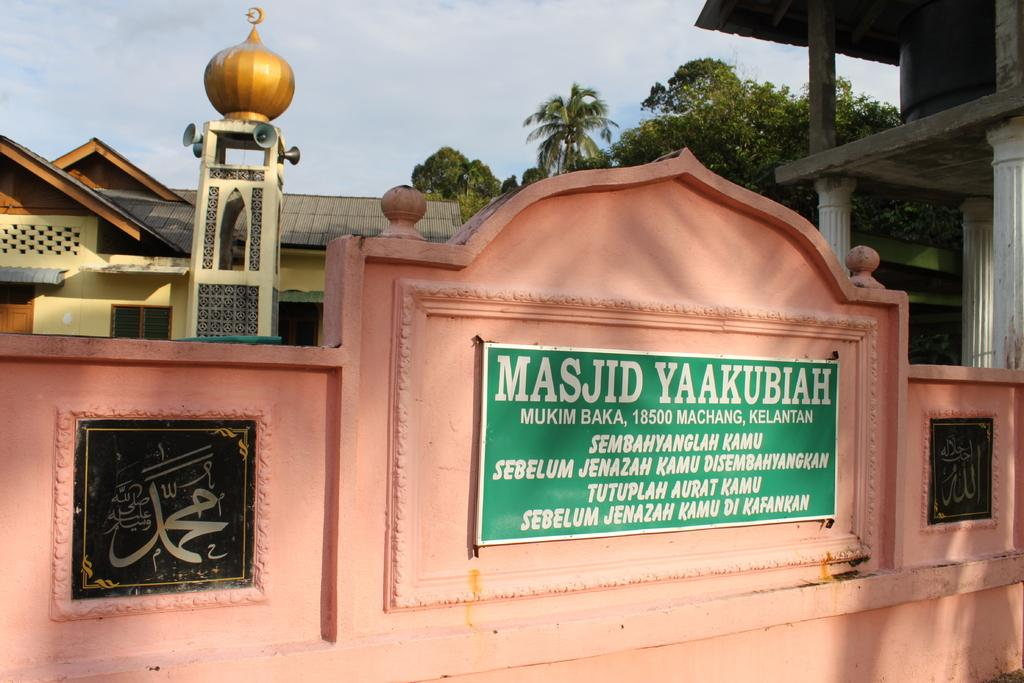What is the main structure in the center of the image? There is a mosque in the center of the image. Is there any text visible in the image? Yes, there is a nameplate with text in the image. What can be seen in the background of the image? Sky, trees, and buildings are visible in the background of the image. What type of hole can be seen in the cloth covering the minaret of the mosque in the image? There is no cloth or hole present in the image; the mosque is not depicted as having a cloth covering its minaret. 